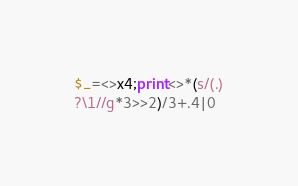<code> <loc_0><loc_0><loc_500><loc_500><_Perl_>$_=<>x4;print<>*(s/(.)
?\1//g*3>>2)/3+.4|0</code> 